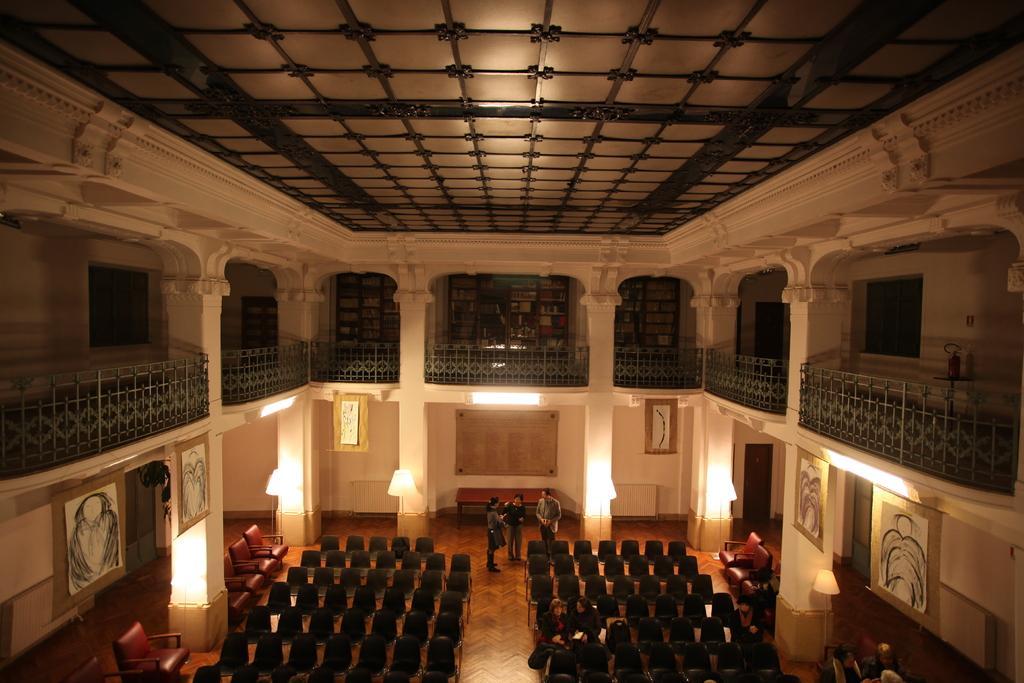Please provide a concise description of this image. In this image I can see the interior of the building which is cream in color. I can see the railing, the ceiling, few lights, few persons standing and few chairs on the floor. I can see few boards attached to the building. 